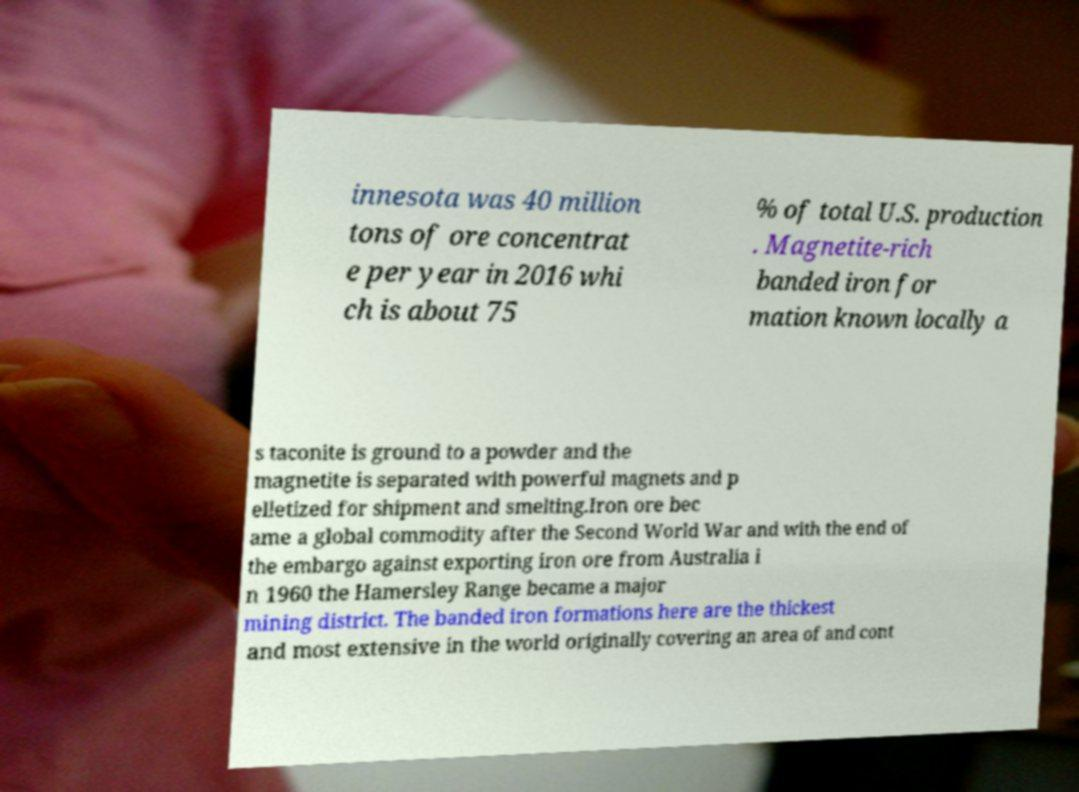Please identify and transcribe the text found in this image. innesota was 40 million tons of ore concentrat e per year in 2016 whi ch is about 75 % of total U.S. production . Magnetite-rich banded iron for mation known locally a s taconite is ground to a powder and the magnetite is separated with powerful magnets and p elletized for shipment and smelting.Iron ore bec ame a global commodity after the Second World War and with the end of the embargo against exporting iron ore from Australia i n 1960 the Hamersley Range became a major mining district. The banded iron formations here are the thickest and most extensive in the world originally covering an area of and cont 